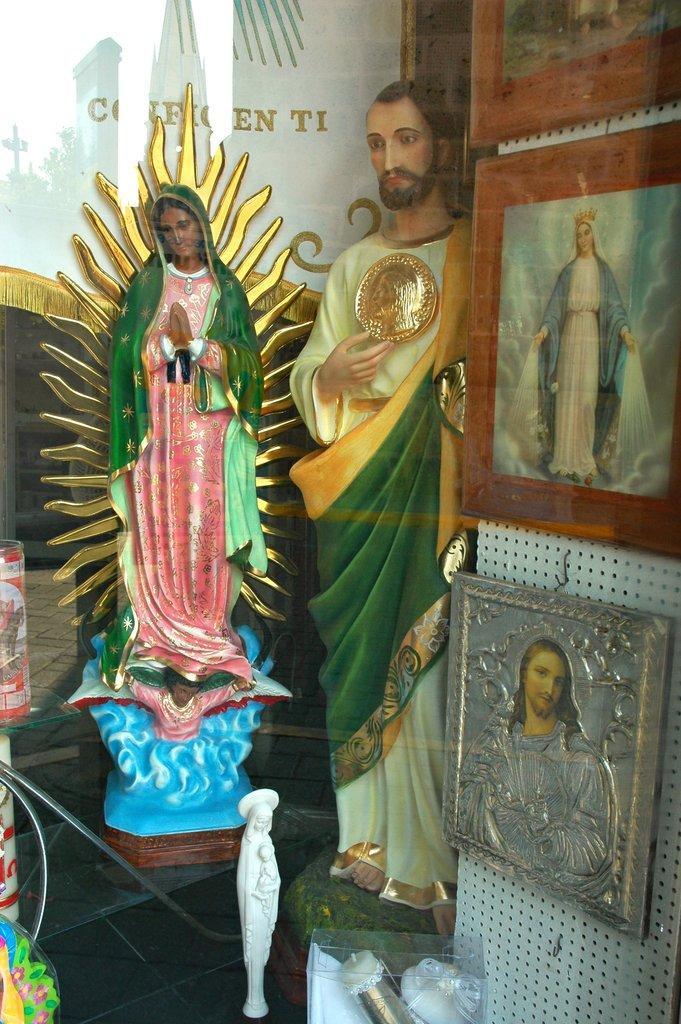Could you give a brief overview of what you see in this image? In the picture we can see some sculptures of Jesus and we can see some photo frames which are on the wall. 